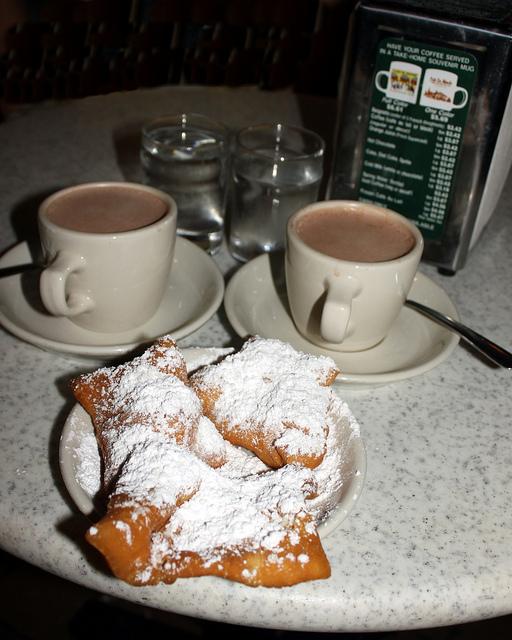Is that flour or powdered sugar on the plate?
Be succinct. Powdered sugar. What is in the mugs?
Give a very brief answer. Coffee. What is on the plates?
Give a very brief answer. Beignets. What is on this plate?
Concise answer only. Pastry. 